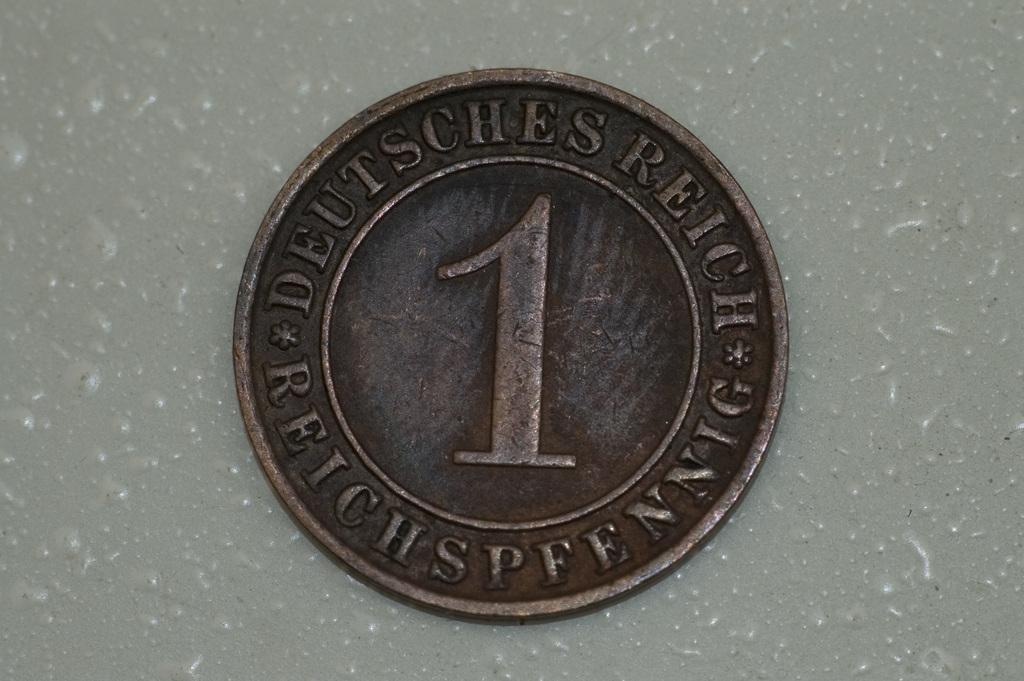Provide a one-sentence caption for the provided image. A brown coin with writing that says DEUTSCHES REICH*REICHSPFENNIG*. 